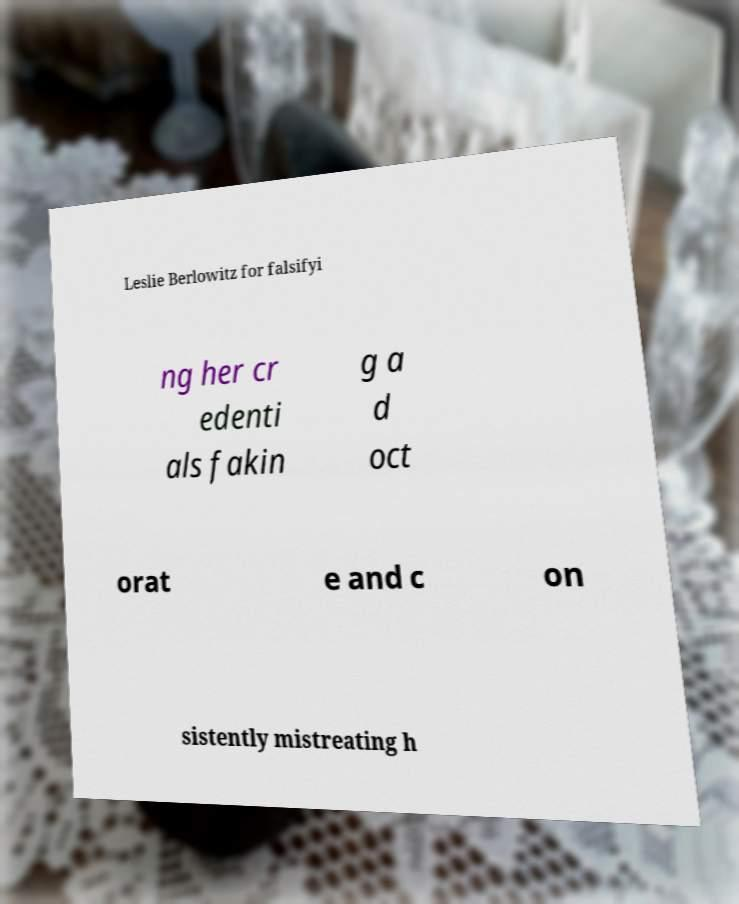What messages or text are displayed in this image? I need them in a readable, typed format. Leslie Berlowitz for falsifyi ng her cr edenti als fakin g a d oct orat e and c on sistently mistreating h 